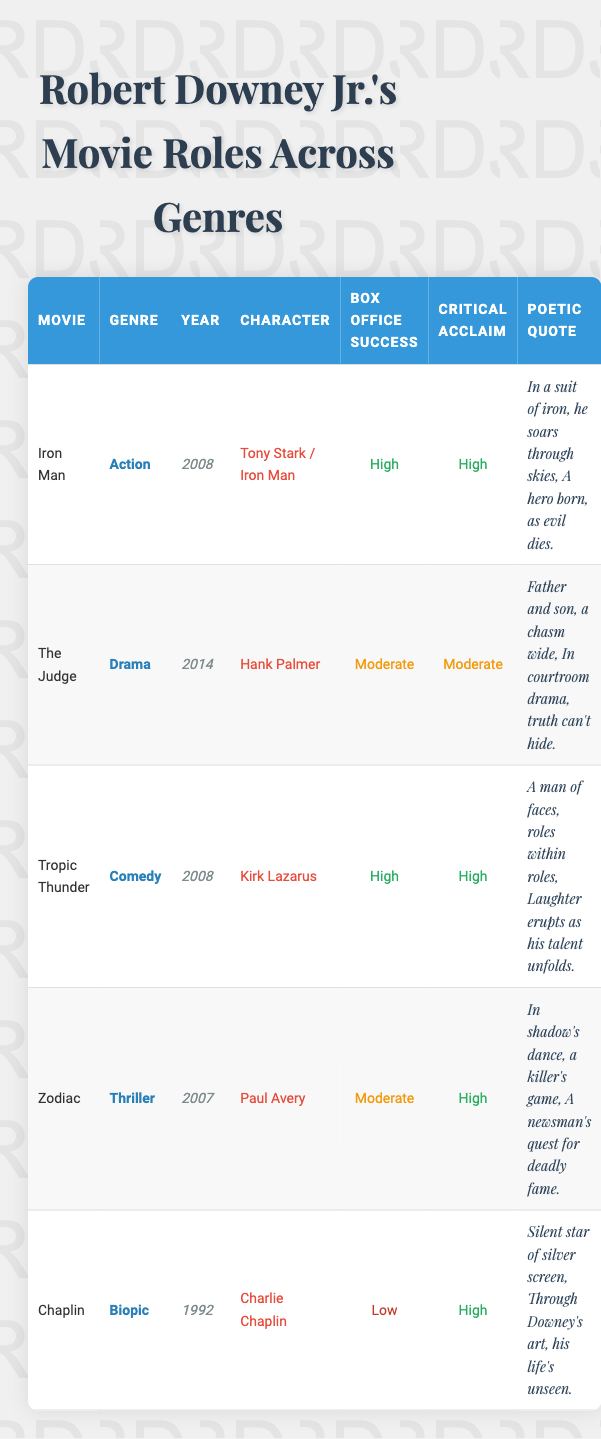What genre does "Iron Man" belong to? The genre of "Iron Man" is listed in the table under the "Genre" column, where it states "Action."
Answer: Action Which movie had the highest box office success? By inspecting the "Box Office Success" column, "Iron Man" and "Tropic Thunder" both indicate "High," but "Iron Man" is the first entry with "High."
Answer: Iron Man Was "Chaplin" a biopic? Looking at the "Genre" column, "Chaplin" is classified as "Biopic," confirming this fact.
Answer: Yes What is the character played by Robert Downey Jr. in "Zodiac"? The character listed under the "Character" column for the movie "Zodiac" is "Paul Avery."
Answer: Paul Avery Which movie received "High" critical acclaim but had "Moderate" box office success? In the "Critical Acclaim" column, "Zodiac" is marked as "High," and in the "Box Office Success" column, it is listed as "Moderate."
Answer: Zodiac What is the average box office success rating of Downey's movies? The average is calculated by assigning numerical values to the box office ratings: High = 2, Moderate = 1, Low = 0. There are three highs (2), one moderate (1), and one low (0): (2 + 2 + 1 + 1 + 0) / 5 = 1.2, which corresponds to a rating between "Moderate" and "High."
Answer: Moderate In which year did Robert Downey Jr. portray Tony Stark? Referring to the "Year" column for the movie "Iron Man," it is noted that he portrayed the character in 2008.
Answer: 2008 Which genre had the lowest box office success? The "Box Office Success" column indicates that "Chaplin" has a rating of "Low," making it the genre with the lowest success.
Answer: Biopic How many movies listed in the table have received "High" critical acclaim? There are four instances from the "Critical Acclaim" column marked as "High"—these correspond to "Iron Man," "Tropic Thunder," "Zodiac," and "Chaplin." Counting them gives us four movies.
Answer: Four 